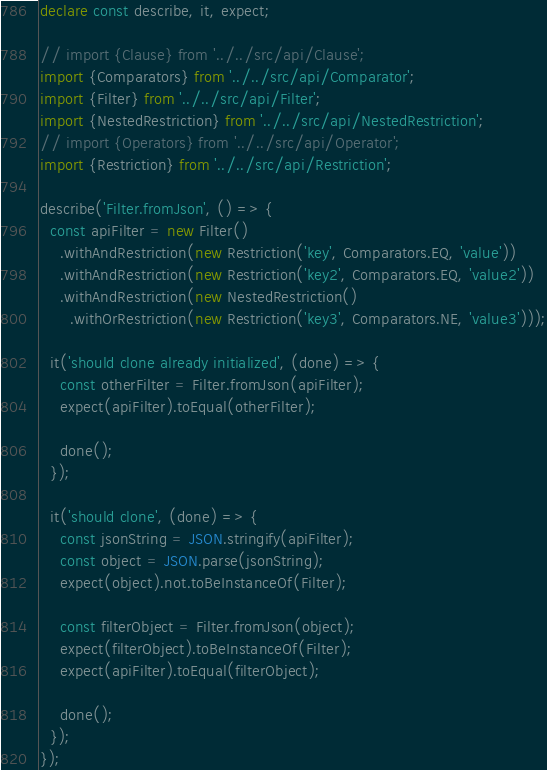<code> <loc_0><loc_0><loc_500><loc_500><_TypeScript_>declare const describe, it, expect;

// import {Clause} from '../../src/api/Clause';
import {Comparators} from '../../src/api/Comparator';
import {Filter} from '../../src/api/Filter';
import {NestedRestriction} from '../../src/api/NestedRestriction';
// import {Operators} from '../../src/api/Operator';
import {Restriction} from '../../src/api/Restriction';

describe('Filter.fromJson', () => {
  const apiFilter = new Filter()
    .withAndRestriction(new Restriction('key', Comparators.EQ, 'value'))
    .withAndRestriction(new Restriction('key2', Comparators.EQ, 'value2'))
    .withAndRestriction(new NestedRestriction()
      .withOrRestriction(new Restriction('key3', Comparators.NE, 'value3')));

  it('should clone already initialized', (done) => {
    const otherFilter = Filter.fromJson(apiFilter);
    expect(apiFilter).toEqual(otherFilter);

    done();
  });

  it('should clone', (done) => {
    const jsonString = JSON.stringify(apiFilter);
    const object = JSON.parse(jsonString);
    expect(object).not.toBeInstanceOf(Filter);

    const filterObject = Filter.fromJson(object);
    expect(filterObject).toBeInstanceOf(Filter);
    expect(apiFilter).toEqual(filterObject);

    done();
  });
});
</code> 